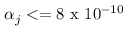Convert formula to latex. <formula><loc_0><loc_0><loc_500><loc_500>\alpha _ { j } < = 8 x 1 0 ^ { - 1 0 }</formula> 